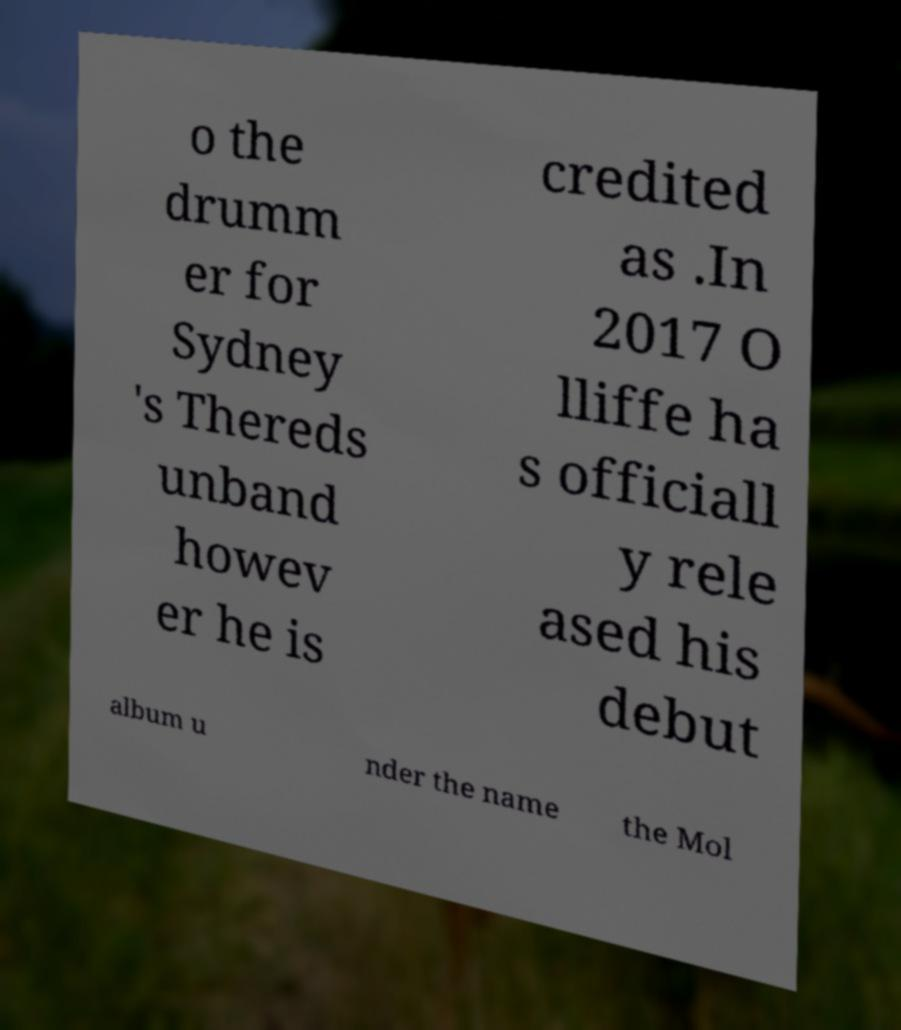There's text embedded in this image that I need extracted. Can you transcribe it verbatim? o the drumm er for Sydney 's Thereds unband howev er he is credited as .In 2017 O lliffe ha s officiall y rele ased his debut album u nder the name the Mol 